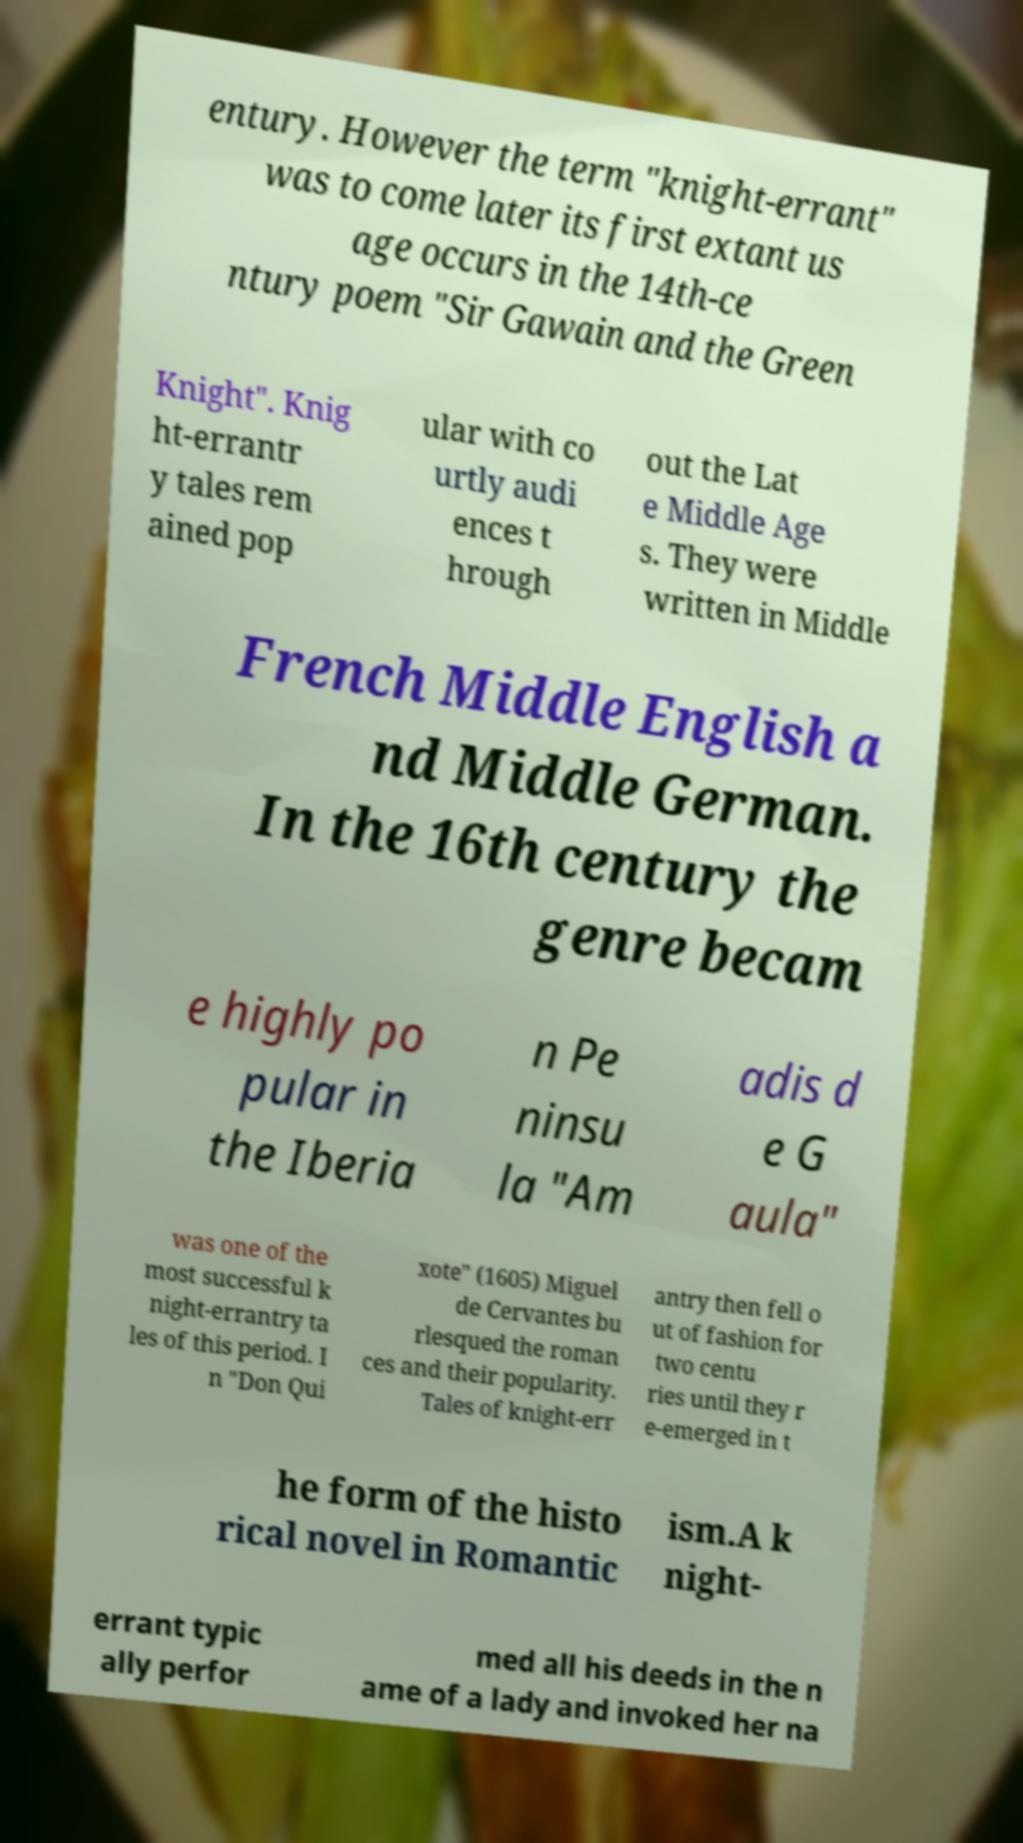For documentation purposes, I need the text within this image transcribed. Could you provide that? entury. However the term "knight-errant" was to come later its first extant us age occurs in the 14th-ce ntury poem "Sir Gawain and the Green Knight". Knig ht-errantr y tales rem ained pop ular with co urtly audi ences t hrough out the Lat e Middle Age s. They were written in Middle French Middle English a nd Middle German. In the 16th century the genre becam e highly po pular in the Iberia n Pe ninsu la "Am adis d e G aula" was one of the most successful k night-errantry ta les of this period. I n "Don Qui xote" (1605) Miguel de Cervantes bu rlesqued the roman ces and their popularity. Tales of knight-err antry then fell o ut of fashion for two centu ries until they r e-emerged in t he form of the histo rical novel in Romantic ism.A k night- errant typic ally perfor med all his deeds in the n ame of a lady and invoked her na 